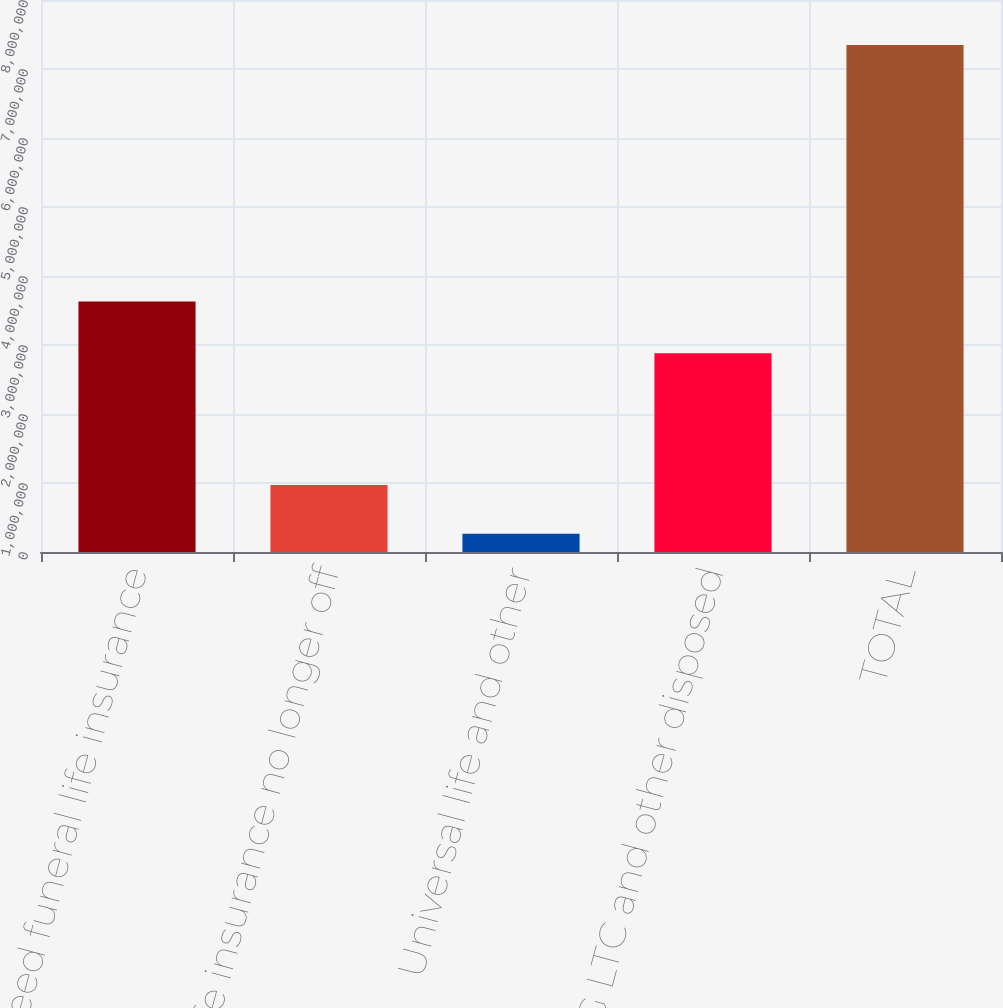Convert chart to OTSL. <chart><loc_0><loc_0><loc_500><loc_500><bar_chart><fcel>Preneed funeral life insurance<fcel>Life insurance no longer off<fcel>Universal life and other<fcel>FFG LTC and other disposed<fcel>TOTAL<nl><fcel>3.6296e+06<fcel>971987<fcel>263360<fcel>2.87922e+06<fcel>7.34963e+06<nl></chart> 